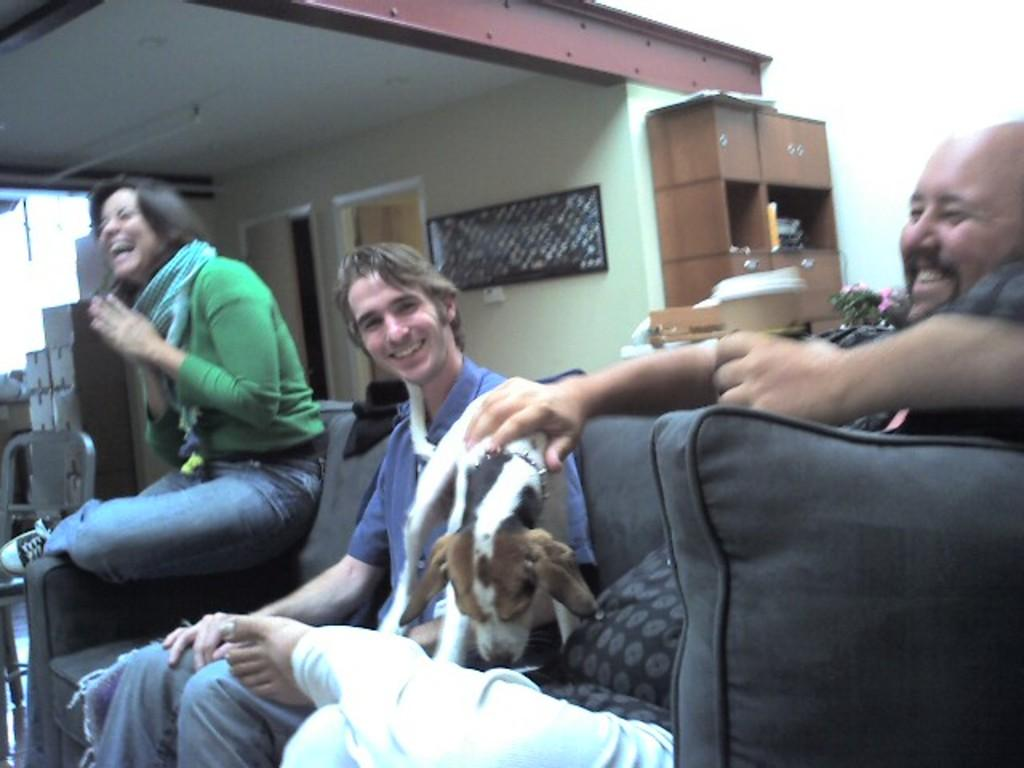How many people are in the image? There is a group of persons in the image. What are the persons doing in the image? The persons are sitting on a couch. What other living creature is present in the image? There is a dog in the middle of the image. What type of territory does the dog claim in the image? There is no indication of the dog claiming any territory in the image. 